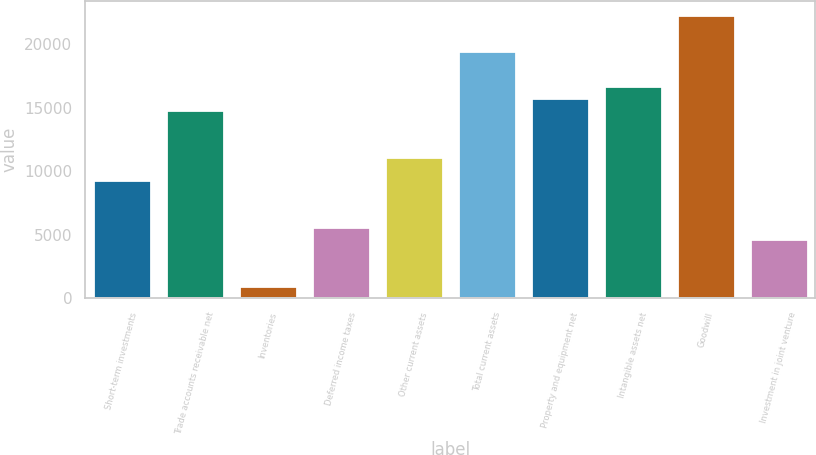<chart> <loc_0><loc_0><loc_500><loc_500><bar_chart><fcel>Short-term investments<fcel>Trade accounts receivable net<fcel>Inventories<fcel>Deferred income taxes<fcel>Other current assets<fcel>Total current assets<fcel>Property and equipment net<fcel>Intangible assets net<fcel>Goodwill<fcel>Investment in joint venture<nl><fcel>9289<fcel>14857.6<fcel>936.1<fcel>5576.6<fcel>11145.2<fcel>19498.1<fcel>15785.7<fcel>16713.8<fcel>22282.4<fcel>4648.5<nl></chart> 